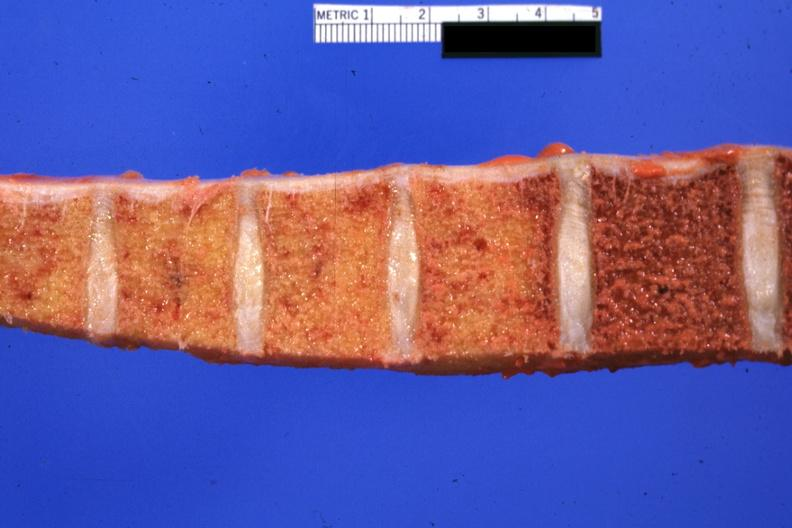how does this image show vertebral column?
Answer the question using a single word or phrase. With obvious fibrosis involving four of the bodies but not the remaining one in photo cause of lesion not proved but almost certainly due to radiation for lung carcinoma and meningeal carcinomatosis 